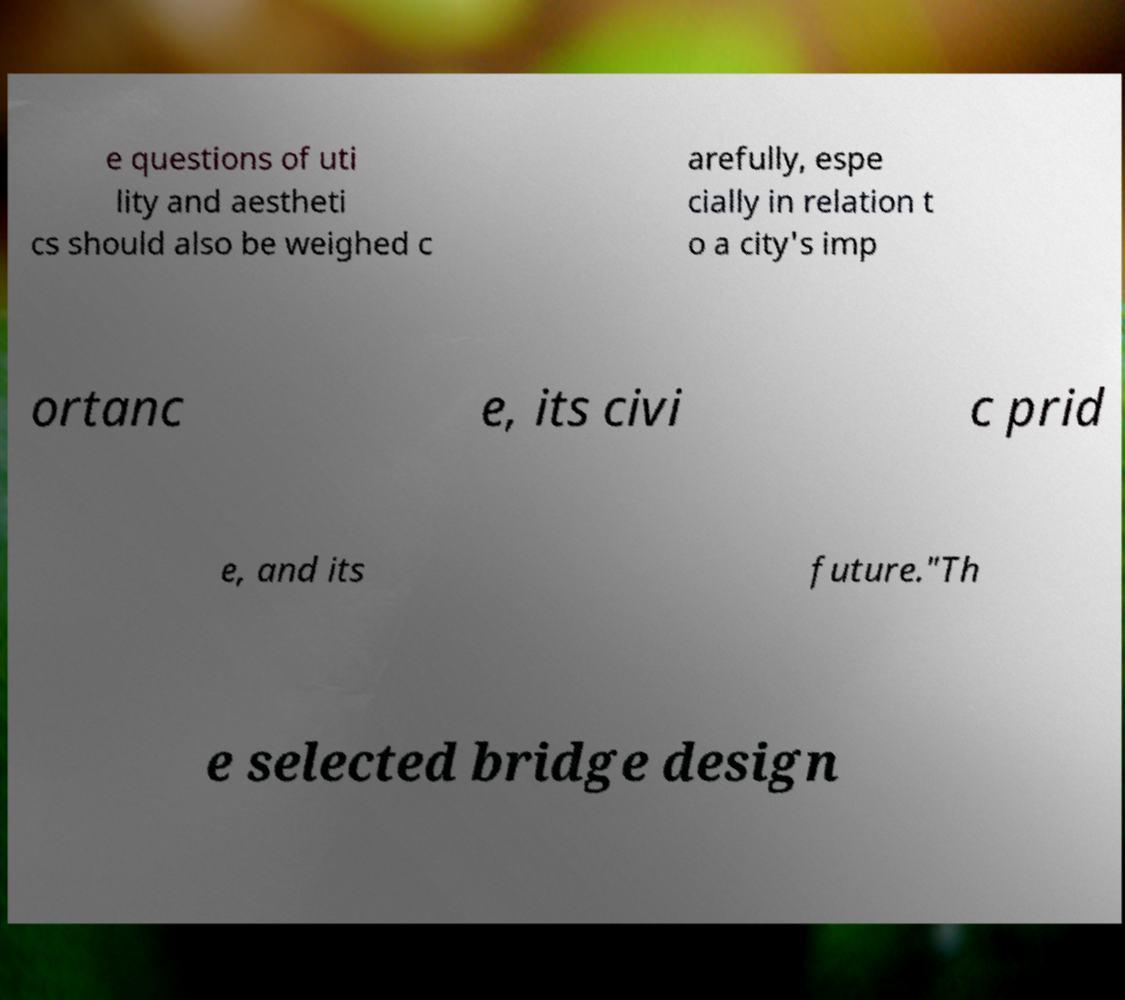I need the written content from this picture converted into text. Can you do that? e questions of uti lity and aestheti cs should also be weighed c arefully, espe cially in relation t o a city's imp ortanc e, its civi c prid e, and its future."Th e selected bridge design 